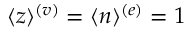<formula> <loc_0><loc_0><loc_500><loc_500>\langle z \rangle ^ { ( v ) } = \langle n \rangle ^ { ( e ) } = 1</formula> 